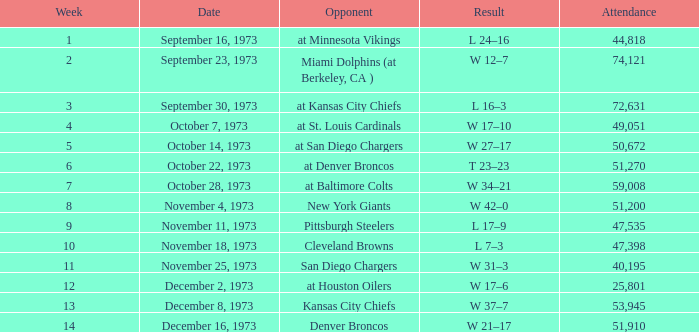What is the attendance for the game against the Kansas City Chiefs earlier than week 13? None. 